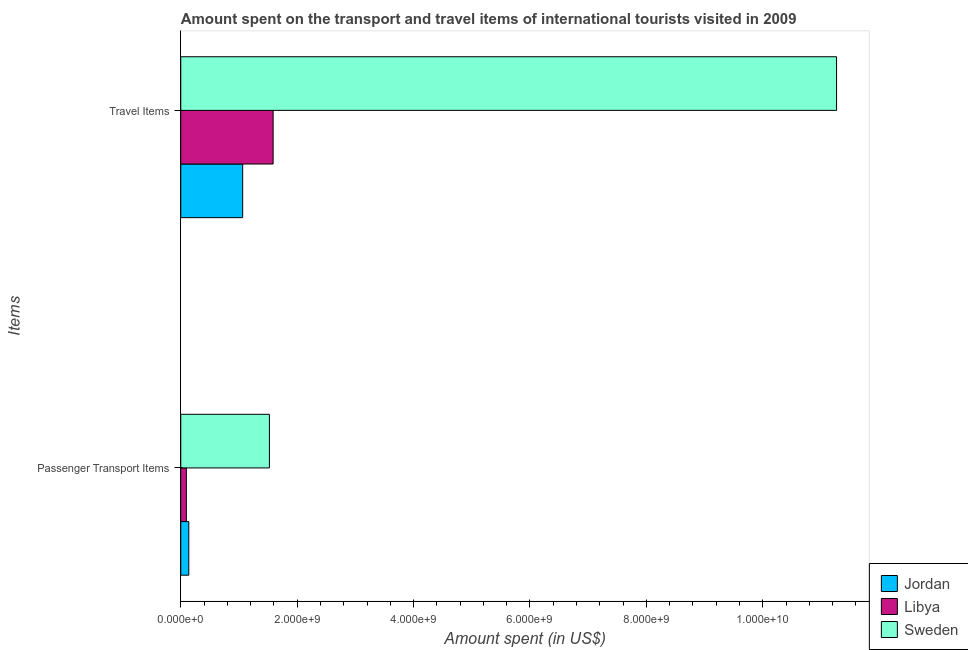How many bars are there on the 2nd tick from the top?
Your answer should be very brief. 3. How many bars are there on the 1st tick from the bottom?
Provide a short and direct response. 3. What is the label of the 2nd group of bars from the top?
Your answer should be very brief. Passenger Transport Items. What is the amount spent in travel items in Libya?
Offer a terse response. 1.59e+09. Across all countries, what is the maximum amount spent on passenger transport items?
Give a very brief answer. 1.52e+09. Across all countries, what is the minimum amount spent in travel items?
Give a very brief answer. 1.06e+09. In which country was the amount spent in travel items minimum?
Offer a terse response. Jordan. What is the total amount spent in travel items in the graph?
Ensure brevity in your answer.  1.39e+1. What is the difference between the amount spent in travel items in Sweden and that in Jordan?
Your answer should be very brief. 1.02e+1. What is the difference between the amount spent in travel items in Sweden and the amount spent on passenger transport items in Libya?
Offer a very short reply. 1.12e+1. What is the average amount spent in travel items per country?
Your answer should be compact. 4.64e+09. What is the difference between the amount spent in travel items and amount spent on passenger transport items in Jordan?
Provide a succinct answer. 9.26e+08. In how many countries, is the amount spent on passenger transport items greater than 8400000000 US$?
Offer a very short reply. 0. What is the ratio of the amount spent on passenger transport items in Sweden to that in Libya?
Make the answer very short. 15.86. Is the amount spent in travel items in Libya less than that in Sweden?
Your answer should be compact. Yes. In how many countries, is the amount spent in travel items greater than the average amount spent in travel items taken over all countries?
Make the answer very short. 1. What does the 2nd bar from the top in Travel Items represents?
Offer a very short reply. Libya. What does the 1st bar from the bottom in Travel Items represents?
Your response must be concise. Jordan. How many bars are there?
Your answer should be compact. 6. Are all the bars in the graph horizontal?
Your answer should be very brief. Yes. Does the graph contain any zero values?
Offer a very short reply. No. Does the graph contain grids?
Your answer should be very brief. No. Where does the legend appear in the graph?
Ensure brevity in your answer.  Bottom right. What is the title of the graph?
Offer a terse response. Amount spent on the transport and travel items of international tourists visited in 2009. What is the label or title of the X-axis?
Make the answer very short. Amount spent (in US$). What is the label or title of the Y-axis?
Ensure brevity in your answer.  Items. What is the Amount spent (in US$) in Jordan in Passenger Transport Items?
Ensure brevity in your answer.  1.38e+08. What is the Amount spent (in US$) of Libya in Passenger Transport Items?
Your response must be concise. 9.60e+07. What is the Amount spent (in US$) in Sweden in Passenger Transport Items?
Your answer should be very brief. 1.52e+09. What is the Amount spent (in US$) in Jordan in Travel Items?
Your answer should be very brief. 1.06e+09. What is the Amount spent (in US$) of Libya in Travel Items?
Ensure brevity in your answer.  1.59e+09. What is the Amount spent (in US$) in Sweden in Travel Items?
Offer a very short reply. 1.13e+1. Across all Items, what is the maximum Amount spent (in US$) of Jordan?
Your answer should be very brief. 1.06e+09. Across all Items, what is the maximum Amount spent (in US$) of Libya?
Offer a terse response. 1.59e+09. Across all Items, what is the maximum Amount spent (in US$) of Sweden?
Give a very brief answer. 1.13e+1. Across all Items, what is the minimum Amount spent (in US$) in Jordan?
Your answer should be compact. 1.38e+08. Across all Items, what is the minimum Amount spent (in US$) in Libya?
Your answer should be very brief. 9.60e+07. Across all Items, what is the minimum Amount spent (in US$) in Sweden?
Give a very brief answer. 1.52e+09. What is the total Amount spent (in US$) of Jordan in the graph?
Keep it short and to the point. 1.20e+09. What is the total Amount spent (in US$) in Libya in the graph?
Give a very brief answer. 1.68e+09. What is the total Amount spent (in US$) of Sweden in the graph?
Make the answer very short. 1.28e+1. What is the difference between the Amount spent (in US$) of Jordan in Passenger Transport Items and that in Travel Items?
Your response must be concise. -9.26e+08. What is the difference between the Amount spent (in US$) in Libya in Passenger Transport Items and that in Travel Items?
Offer a terse response. -1.49e+09. What is the difference between the Amount spent (in US$) in Sweden in Passenger Transport Items and that in Travel Items?
Give a very brief answer. -9.74e+09. What is the difference between the Amount spent (in US$) in Jordan in Passenger Transport Items and the Amount spent (in US$) in Libya in Travel Items?
Make the answer very short. -1.45e+09. What is the difference between the Amount spent (in US$) of Jordan in Passenger Transport Items and the Amount spent (in US$) of Sweden in Travel Items?
Your response must be concise. -1.11e+1. What is the difference between the Amount spent (in US$) of Libya in Passenger Transport Items and the Amount spent (in US$) of Sweden in Travel Items?
Ensure brevity in your answer.  -1.12e+1. What is the average Amount spent (in US$) in Jordan per Items?
Your answer should be compact. 6.01e+08. What is the average Amount spent (in US$) of Libya per Items?
Provide a short and direct response. 8.42e+08. What is the average Amount spent (in US$) of Sweden per Items?
Your answer should be very brief. 6.40e+09. What is the difference between the Amount spent (in US$) in Jordan and Amount spent (in US$) in Libya in Passenger Transport Items?
Offer a very short reply. 4.20e+07. What is the difference between the Amount spent (in US$) in Jordan and Amount spent (in US$) in Sweden in Passenger Transport Items?
Make the answer very short. -1.38e+09. What is the difference between the Amount spent (in US$) in Libya and Amount spent (in US$) in Sweden in Passenger Transport Items?
Make the answer very short. -1.43e+09. What is the difference between the Amount spent (in US$) of Jordan and Amount spent (in US$) of Libya in Travel Items?
Offer a very short reply. -5.23e+08. What is the difference between the Amount spent (in US$) in Jordan and Amount spent (in US$) in Sweden in Travel Items?
Your response must be concise. -1.02e+1. What is the difference between the Amount spent (in US$) in Libya and Amount spent (in US$) in Sweden in Travel Items?
Your answer should be very brief. -9.68e+09. What is the ratio of the Amount spent (in US$) of Jordan in Passenger Transport Items to that in Travel Items?
Give a very brief answer. 0.13. What is the ratio of the Amount spent (in US$) of Libya in Passenger Transport Items to that in Travel Items?
Your answer should be very brief. 0.06. What is the ratio of the Amount spent (in US$) of Sweden in Passenger Transport Items to that in Travel Items?
Your answer should be very brief. 0.14. What is the difference between the highest and the second highest Amount spent (in US$) of Jordan?
Offer a very short reply. 9.26e+08. What is the difference between the highest and the second highest Amount spent (in US$) in Libya?
Your response must be concise. 1.49e+09. What is the difference between the highest and the second highest Amount spent (in US$) in Sweden?
Provide a succinct answer. 9.74e+09. What is the difference between the highest and the lowest Amount spent (in US$) in Jordan?
Give a very brief answer. 9.26e+08. What is the difference between the highest and the lowest Amount spent (in US$) in Libya?
Provide a short and direct response. 1.49e+09. What is the difference between the highest and the lowest Amount spent (in US$) in Sweden?
Keep it short and to the point. 9.74e+09. 